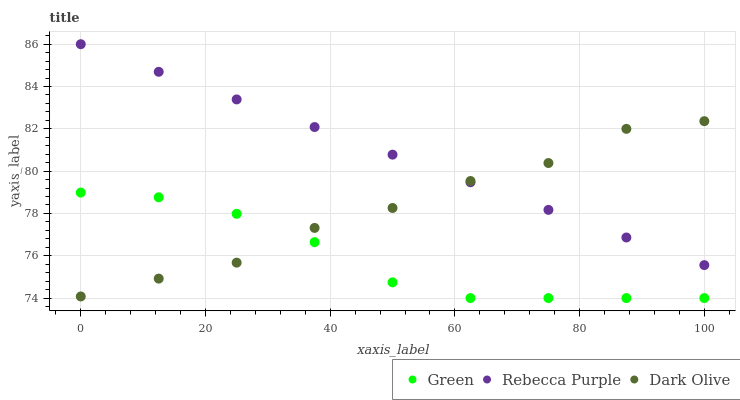Does Green have the minimum area under the curve?
Answer yes or no. Yes. Does Rebecca Purple have the maximum area under the curve?
Answer yes or no. Yes. Does Rebecca Purple have the minimum area under the curve?
Answer yes or no. No. Does Green have the maximum area under the curve?
Answer yes or no. No. Is Rebecca Purple the smoothest?
Answer yes or no. Yes. Is Dark Olive the roughest?
Answer yes or no. Yes. Is Green the smoothest?
Answer yes or no. No. Is Green the roughest?
Answer yes or no. No. Does Green have the lowest value?
Answer yes or no. Yes. Does Rebecca Purple have the lowest value?
Answer yes or no. No. Does Rebecca Purple have the highest value?
Answer yes or no. Yes. Does Green have the highest value?
Answer yes or no. No. Is Green less than Rebecca Purple?
Answer yes or no. Yes. Is Rebecca Purple greater than Green?
Answer yes or no. Yes. Does Dark Olive intersect Green?
Answer yes or no. Yes. Is Dark Olive less than Green?
Answer yes or no. No. Is Dark Olive greater than Green?
Answer yes or no. No. Does Green intersect Rebecca Purple?
Answer yes or no. No. 